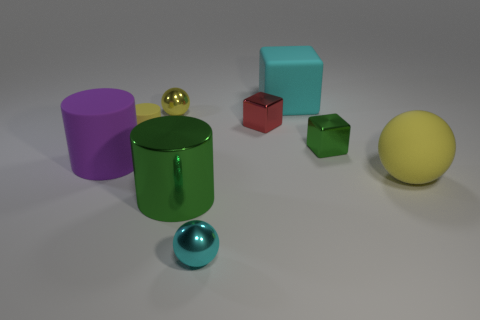There is a ball that is the same size as the green metal cylinder; what is it made of?
Your answer should be very brief. Rubber. What is the cube behind the metal ball behind the tiny cyan object that is on the right side of the yellow cylinder made of?
Offer a terse response. Rubber. What is the color of the tiny rubber object?
Offer a very short reply. Yellow. How many large objects are purple metallic cylinders or red metallic blocks?
Give a very brief answer. 0. What is the material of the cylinder that is the same color as the large sphere?
Ensure brevity in your answer.  Rubber. Are the cube behind the red metal object and the yellow sphere in front of the small yellow sphere made of the same material?
Give a very brief answer. Yes. Is there a matte cube?
Offer a very short reply. Yes. Is the number of large yellow spheres that are left of the cyan rubber block greater than the number of small yellow spheres that are on the right side of the cyan metal ball?
Your answer should be very brief. No. There is a tiny red object that is the same shape as the tiny green metal object; what is it made of?
Offer a very short reply. Metal. Is there any other thing that is the same size as the red cube?
Offer a terse response. Yes. 